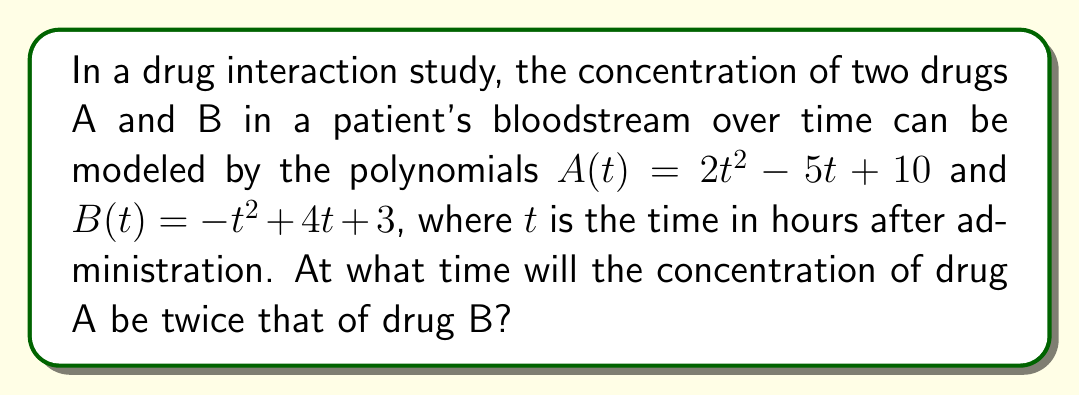Teach me how to tackle this problem. Let's approach this step-by-step:

1) We need to find the time $t$ when $A(t) = 2B(t)$

2) Let's set up the equation:
   $2t^2 - 5t + 10 = 2(-t^2 + 4t + 3)$

3) Expand the right side:
   $2t^2 - 5t + 10 = -2t^2 + 8t + 6$

4) Move all terms to one side:
   $2t^2 - 5t + 10 + 2t^2 - 8t - 6 = 0$

5) Simplify:
   $4t^2 - 13t + 4 = 0$

6) This is a quadratic equation. We can solve it using the quadratic formula:
   $t = \frac{-b \pm \sqrt{b^2 - 4ac}}{2a}$

   Where $a = 4$, $b = -13$, and $c = 4$

7) Substituting these values:
   $t = \frac{13 \pm \sqrt{(-13)^2 - 4(4)(4)}}{2(4)}$

8) Simplify under the square root:
   $t = \frac{13 \pm \sqrt{169 - 64}}{8} = \frac{13 \pm \sqrt{105}}{8}$

9) This gives us two solutions:
   $t_1 = \frac{13 + \sqrt{105}}{8}$ and $t_2 = \frac{13 - \sqrt{105}}{8}$

10) Since time cannot be negative in this context, and $\frac{13 - \sqrt{105}}{8}$ is negative, we discard this solution.

Therefore, the concentration of drug A will be twice that of drug B after $\frac{13 + \sqrt{105}}{8}$ hours.
Answer: $\frac{13 + \sqrt{105}}{8}$ hours 